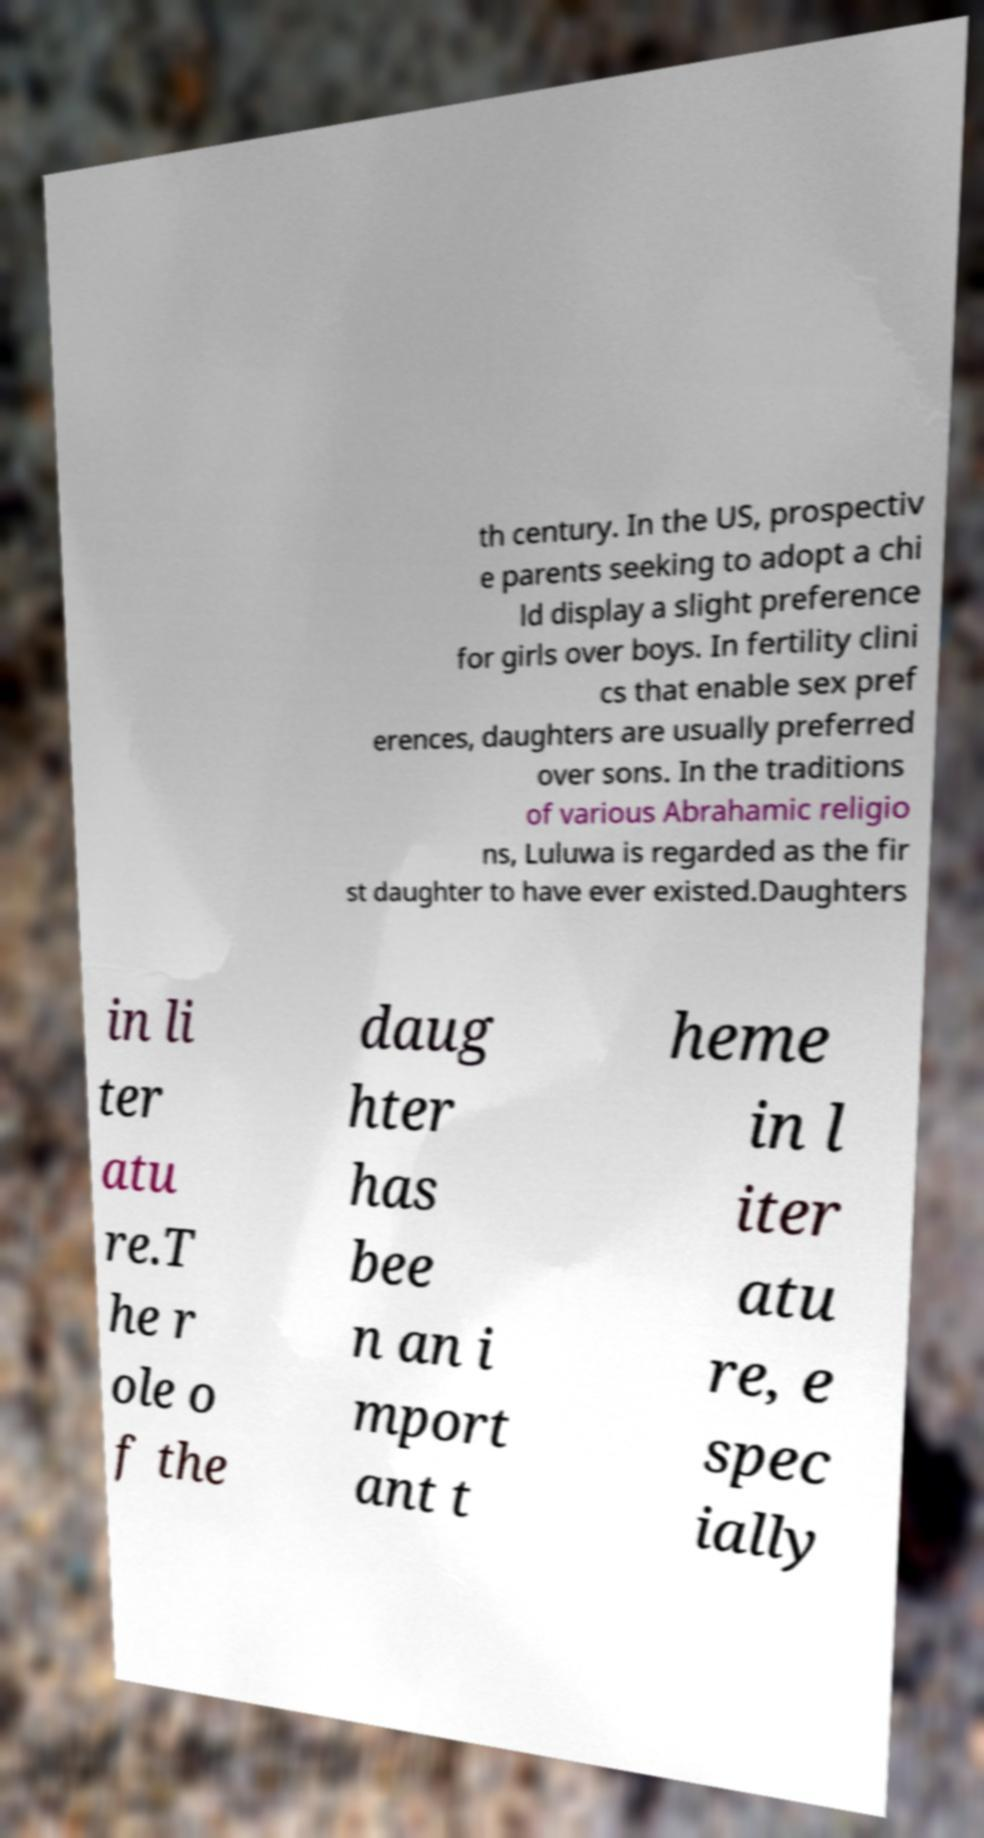Please identify and transcribe the text found in this image. th century. In the US, prospectiv e parents seeking to adopt a chi ld display a slight preference for girls over boys. In fertility clini cs that enable sex pref erences, daughters are usually preferred over sons. In the traditions of various Abrahamic religio ns, Luluwa is regarded as the fir st daughter to have ever existed.Daughters in li ter atu re.T he r ole o f the daug hter has bee n an i mport ant t heme in l iter atu re, e spec ially 